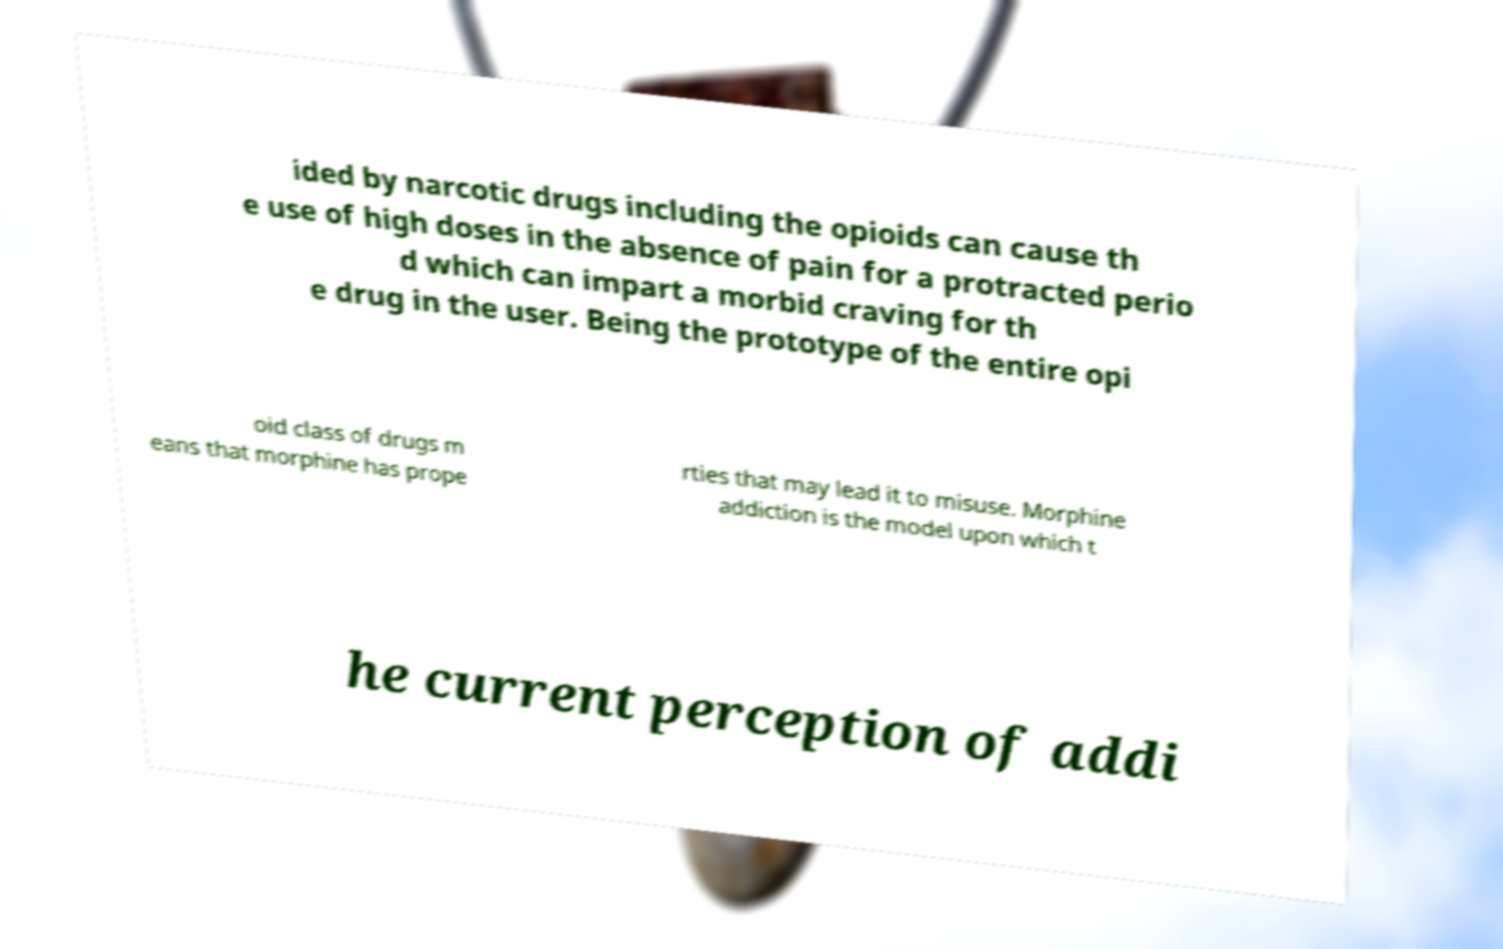Could you assist in decoding the text presented in this image and type it out clearly? ided by narcotic drugs including the opioids can cause th e use of high doses in the absence of pain for a protracted perio d which can impart a morbid craving for th e drug in the user. Being the prototype of the entire opi oid class of drugs m eans that morphine has prope rties that may lead it to misuse. Morphine addiction is the model upon which t he current perception of addi 